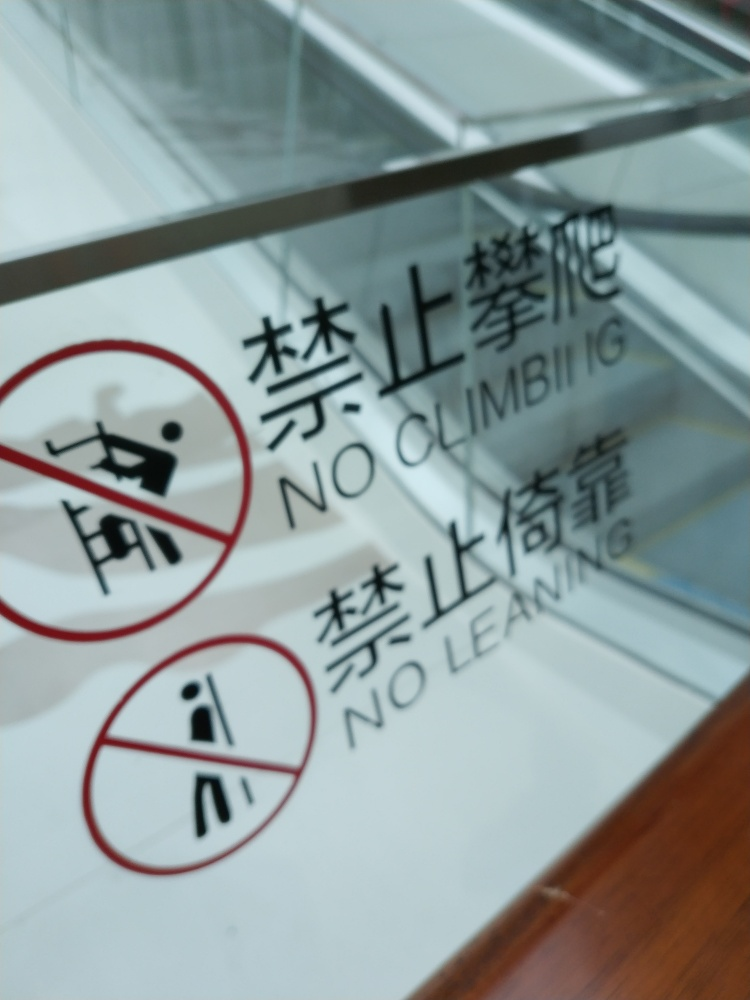What safety messages are displayed in the image? The image shows a sign with two safety messages. One warns against climbing with the phrase 'NO CLIMBING' accompanied by a pictogram of a figure with a slash through it above a railing. The other advises 'NO LEANING' and also includes a similar pictogram with a slash through a figure leaning on a railing. 